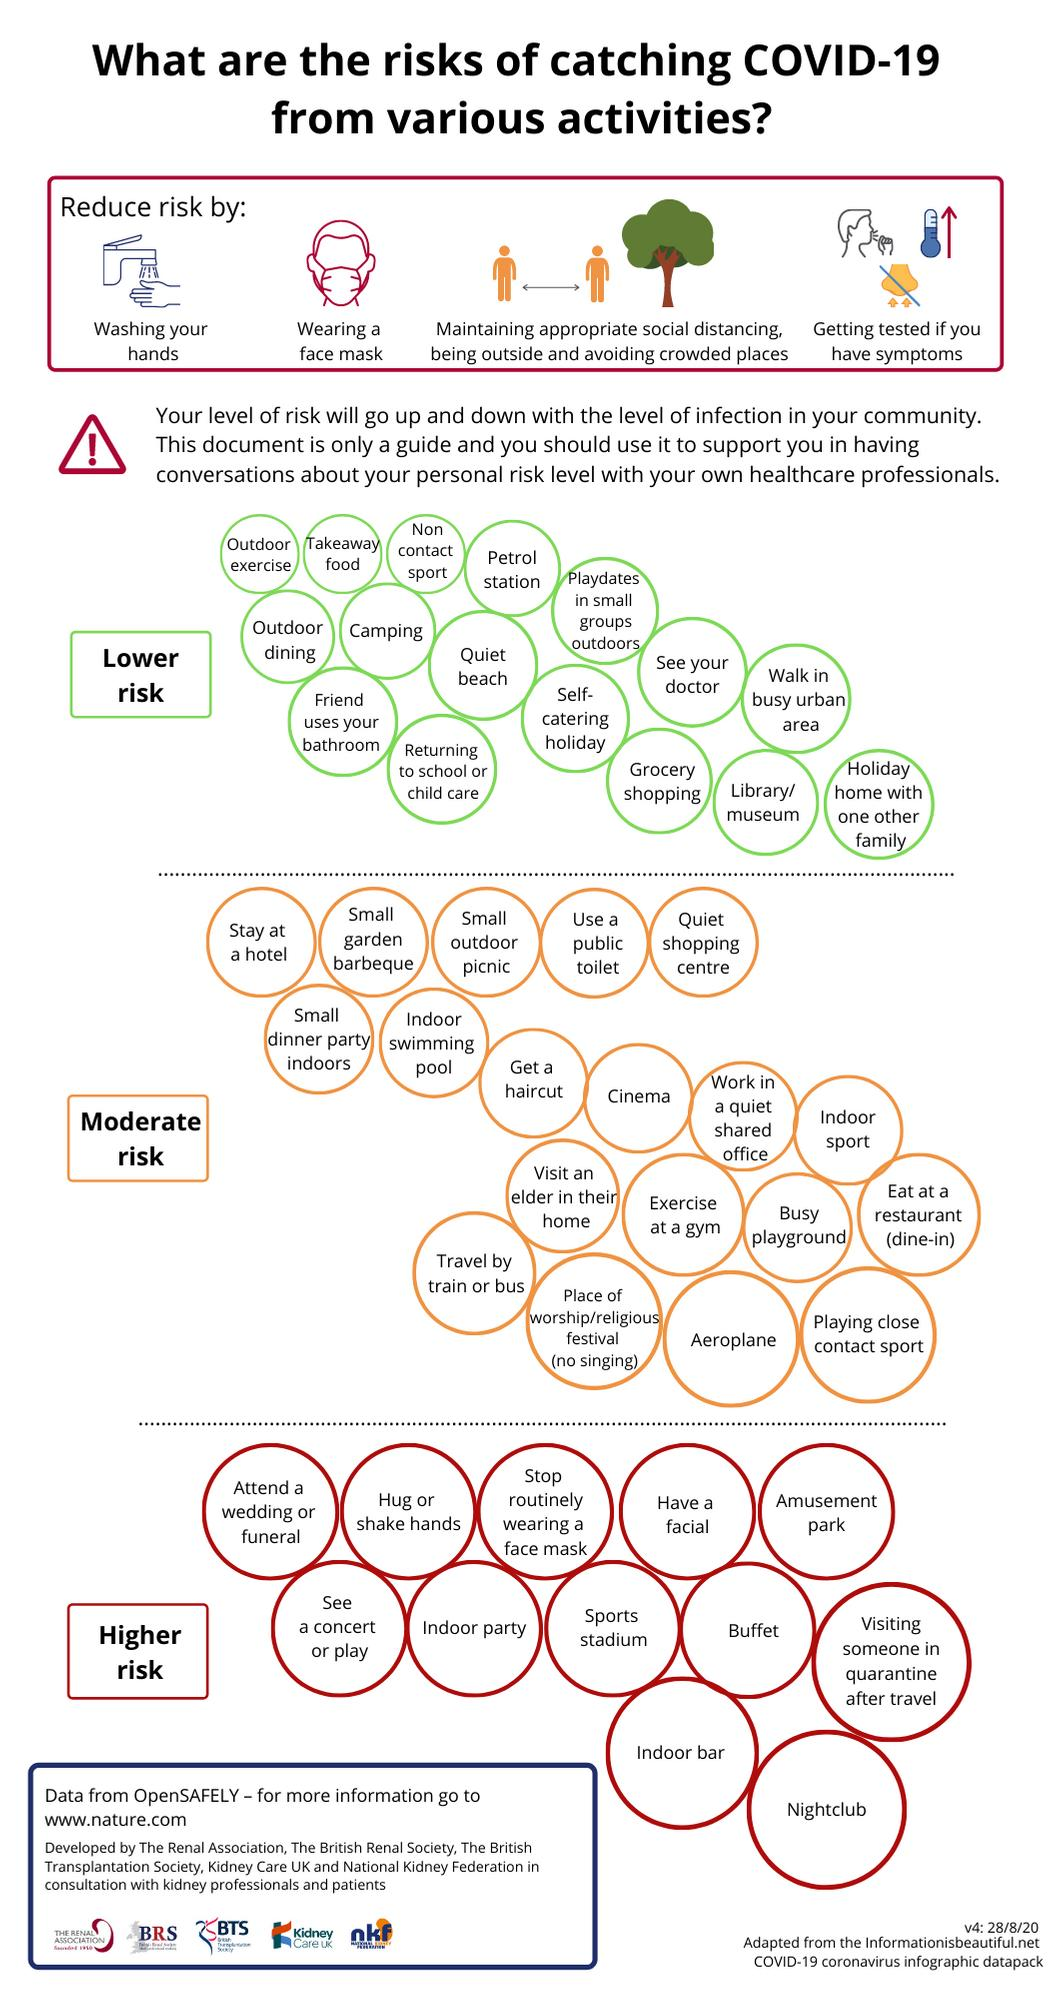Specify some key components in this picture. The info graphic lists 19 activities that are of moderate risk. What are the different categories in which the risks of the coronavirus are divided? There are three of them. The info graphic lists 12 high-risk activities. Walking in a busy urban area and grocery shopping are considered to be lower risk activities during the ongoing COVID-19 pandemic. Activities such as cinema, aeroplane, and indoor sports are categorized under the moderate risk category of the Corona risks. 